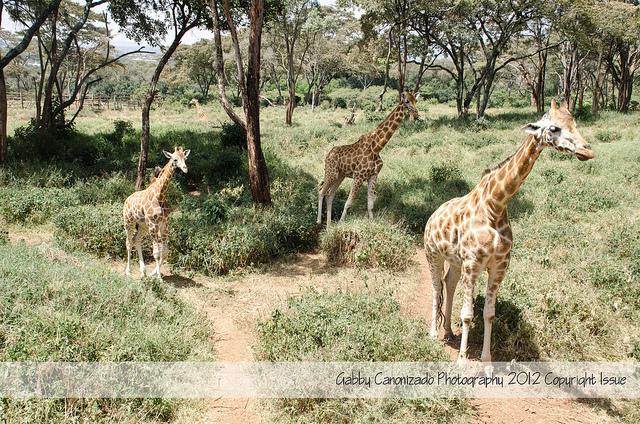Are any of the giraffes facing the trees?
Give a very brief answer. No. What are the smaller animals called?
Concise answer only. Giraffe. How many animals are shown?
Quick response, please. 3. Is there a baby giraffe in this photo?
Short answer required. Yes. 